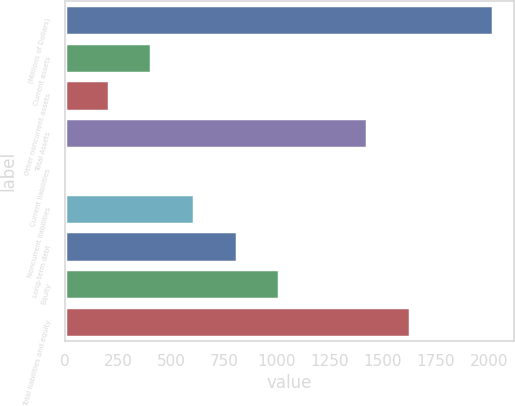<chart> <loc_0><loc_0><loc_500><loc_500><bar_chart><fcel>(Millions of Dollars)<fcel>Current assets<fcel>Other noncurrent assets<fcel>Total Assets<fcel>Current liabilities<fcel>Noncurrent liabilities<fcel>Long-term debt<fcel>Equity<fcel>Total liabilities and equity<nl><fcel>2018<fcel>407.6<fcel>206.3<fcel>1425<fcel>5<fcel>608.9<fcel>810.2<fcel>1011.5<fcel>1626.3<nl></chart> 